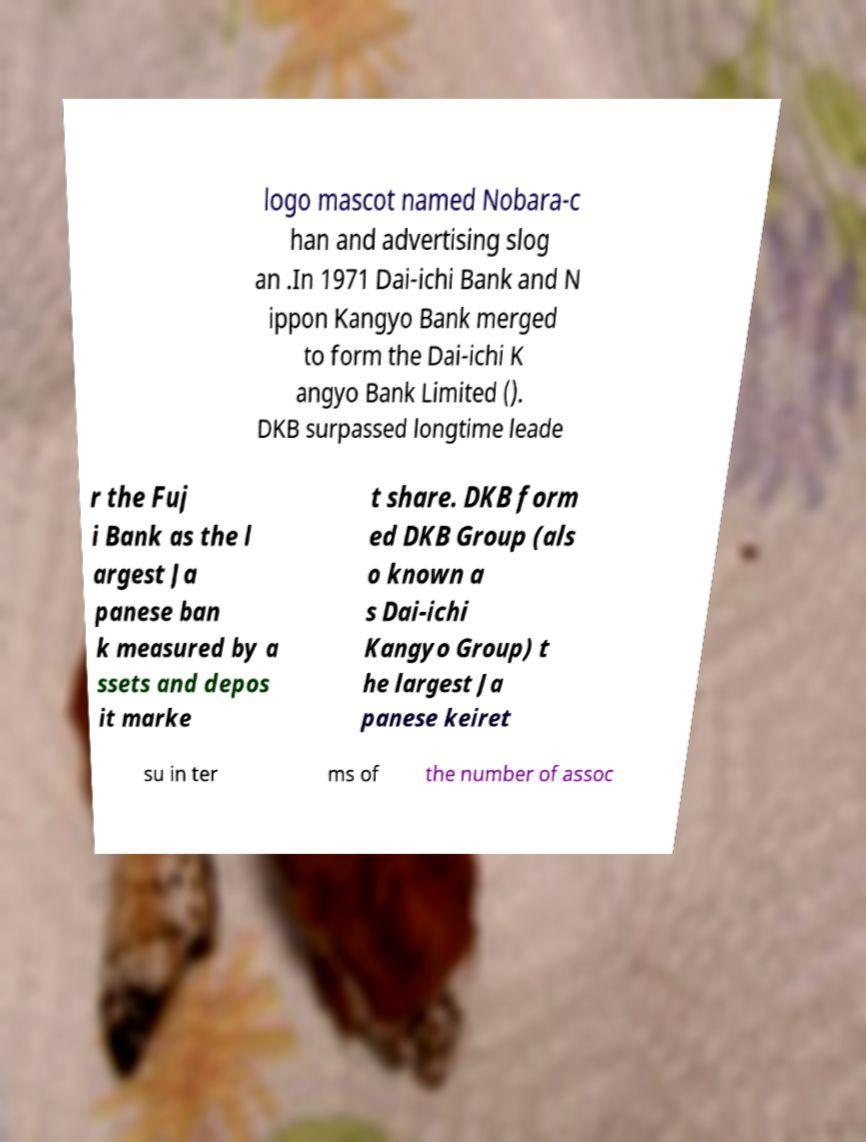Could you assist in decoding the text presented in this image and type it out clearly? logo mascot named Nobara-c han and advertising slog an .In 1971 Dai-ichi Bank and N ippon Kangyo Bank merged to form the Dai-ichi K angyo Bank Limited (). DKB surpassed longtime leade r the Fuj i Bank as the l argest Ja panese ban k measured by a ssets and depos it marke t share. DKB form ed DKB Group (als o known a s Dai-ichi Kangyo Group) t he largest Ja panese keiret su in ter ms of the number of assoc 